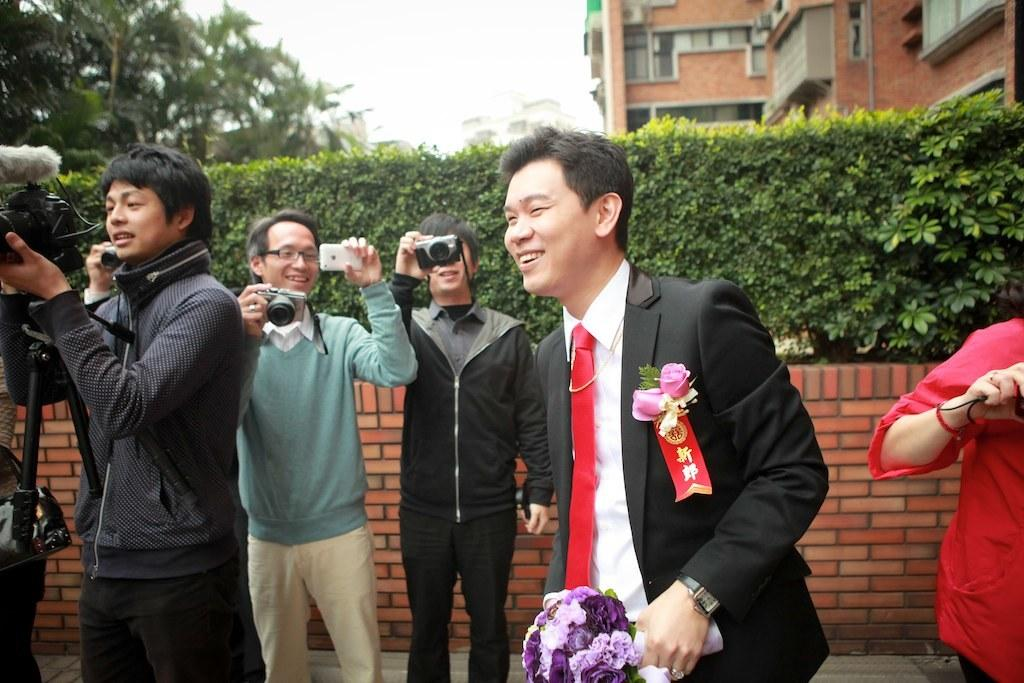What is the main subject of the image? The main subject of the image is a group of people. Where are the people located in the image? The people are standing on the ground in the image. What are some people doing in the image? Some people are holding cameras in their hands. What can be seen in the background of the image? The sky is visible in the background of the image. What type of oatmeal is being served to the people in the image? There is no oatmeal present in the image; the people are holding cameras and standing on the ground. 